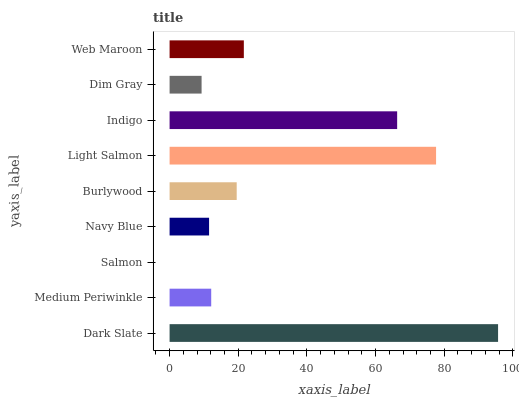Is Salmon the minimum?
Answer yes or no. Yes. Is Dark Slate the maximum?
Answer yes or no. Yes. Is Medium Periwinkle the minimum?
Answer yes or no. No. Is Medium Periwinkle the maximum?
Answer yes or no. No. Is Dark Slate greater than Medium Periwinkle?
Answer yes or no. Yes. Is Medium Periwinkle less than Dark Slate?
Answer yes or no. Yes. Is Medium Periwinkle greater than Dark Slate?
Answer yes or no. No. Is Dark Slate less than Medium Periwinkle?
Answer yes or no. No. Is Burlywood the high median?
Answer yes or no. Yes. Is Burlywood the low median?
Answer yes or no. Yes. Is Salmon the high median?
Answer yes or no. No. Is Indigo the low median?
Answer yes or no. No. 